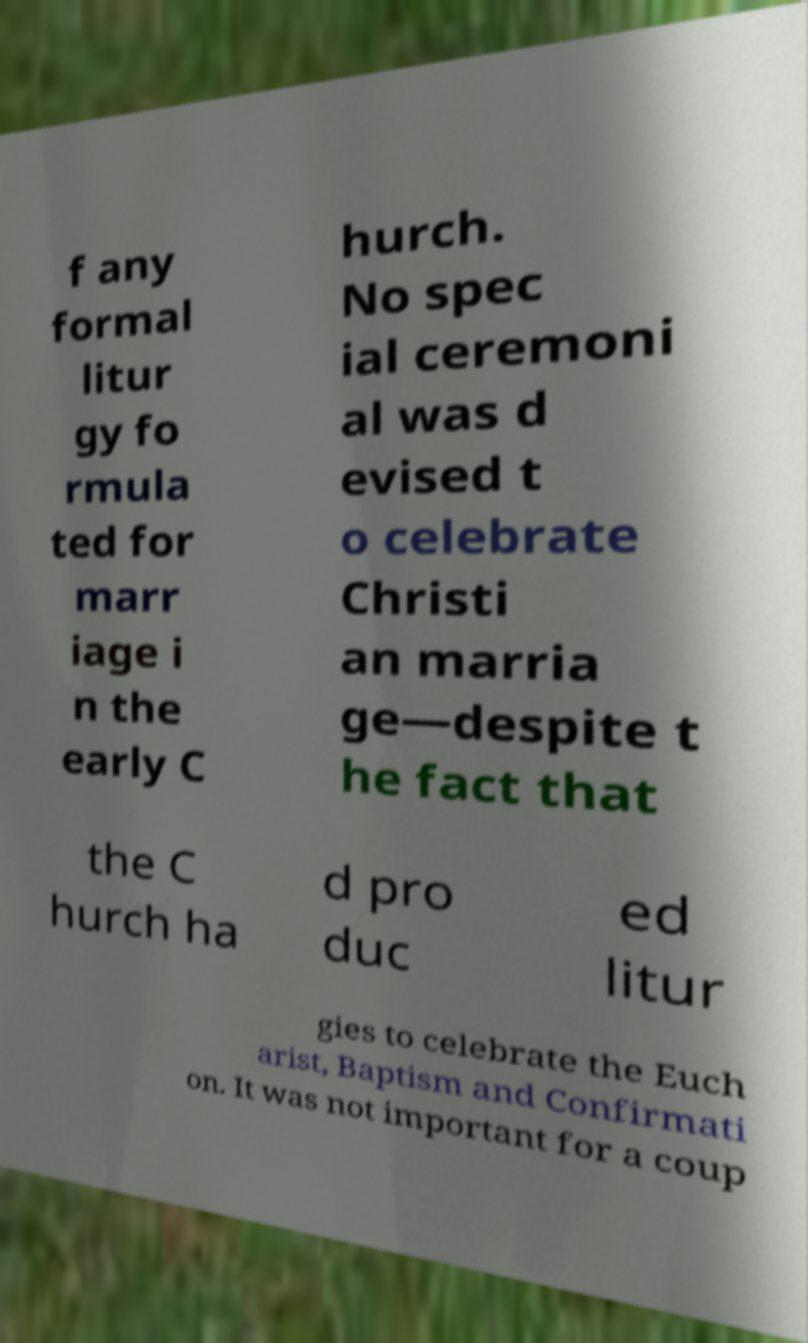Could you extract and type out the text from this image? f any formal litur gy fo rmula ted for marr iage i n the early C hurch. No spec ial ceremoni al was d evised t o celebrate Christi an marria ge—despite t he fact that the C hurch ha d pro duc ed litur gies to celebrate the Euch arist, Baptism and Confirmati on. It was not important for a coup 